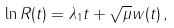Convert formula to latex. <formula><loc_0><loc_0><loc_500><loc_500>\ln R ( t ) = \lambda _ { 1 } t + \sqrt { \mu } w ( t ) \, ,</formula> 